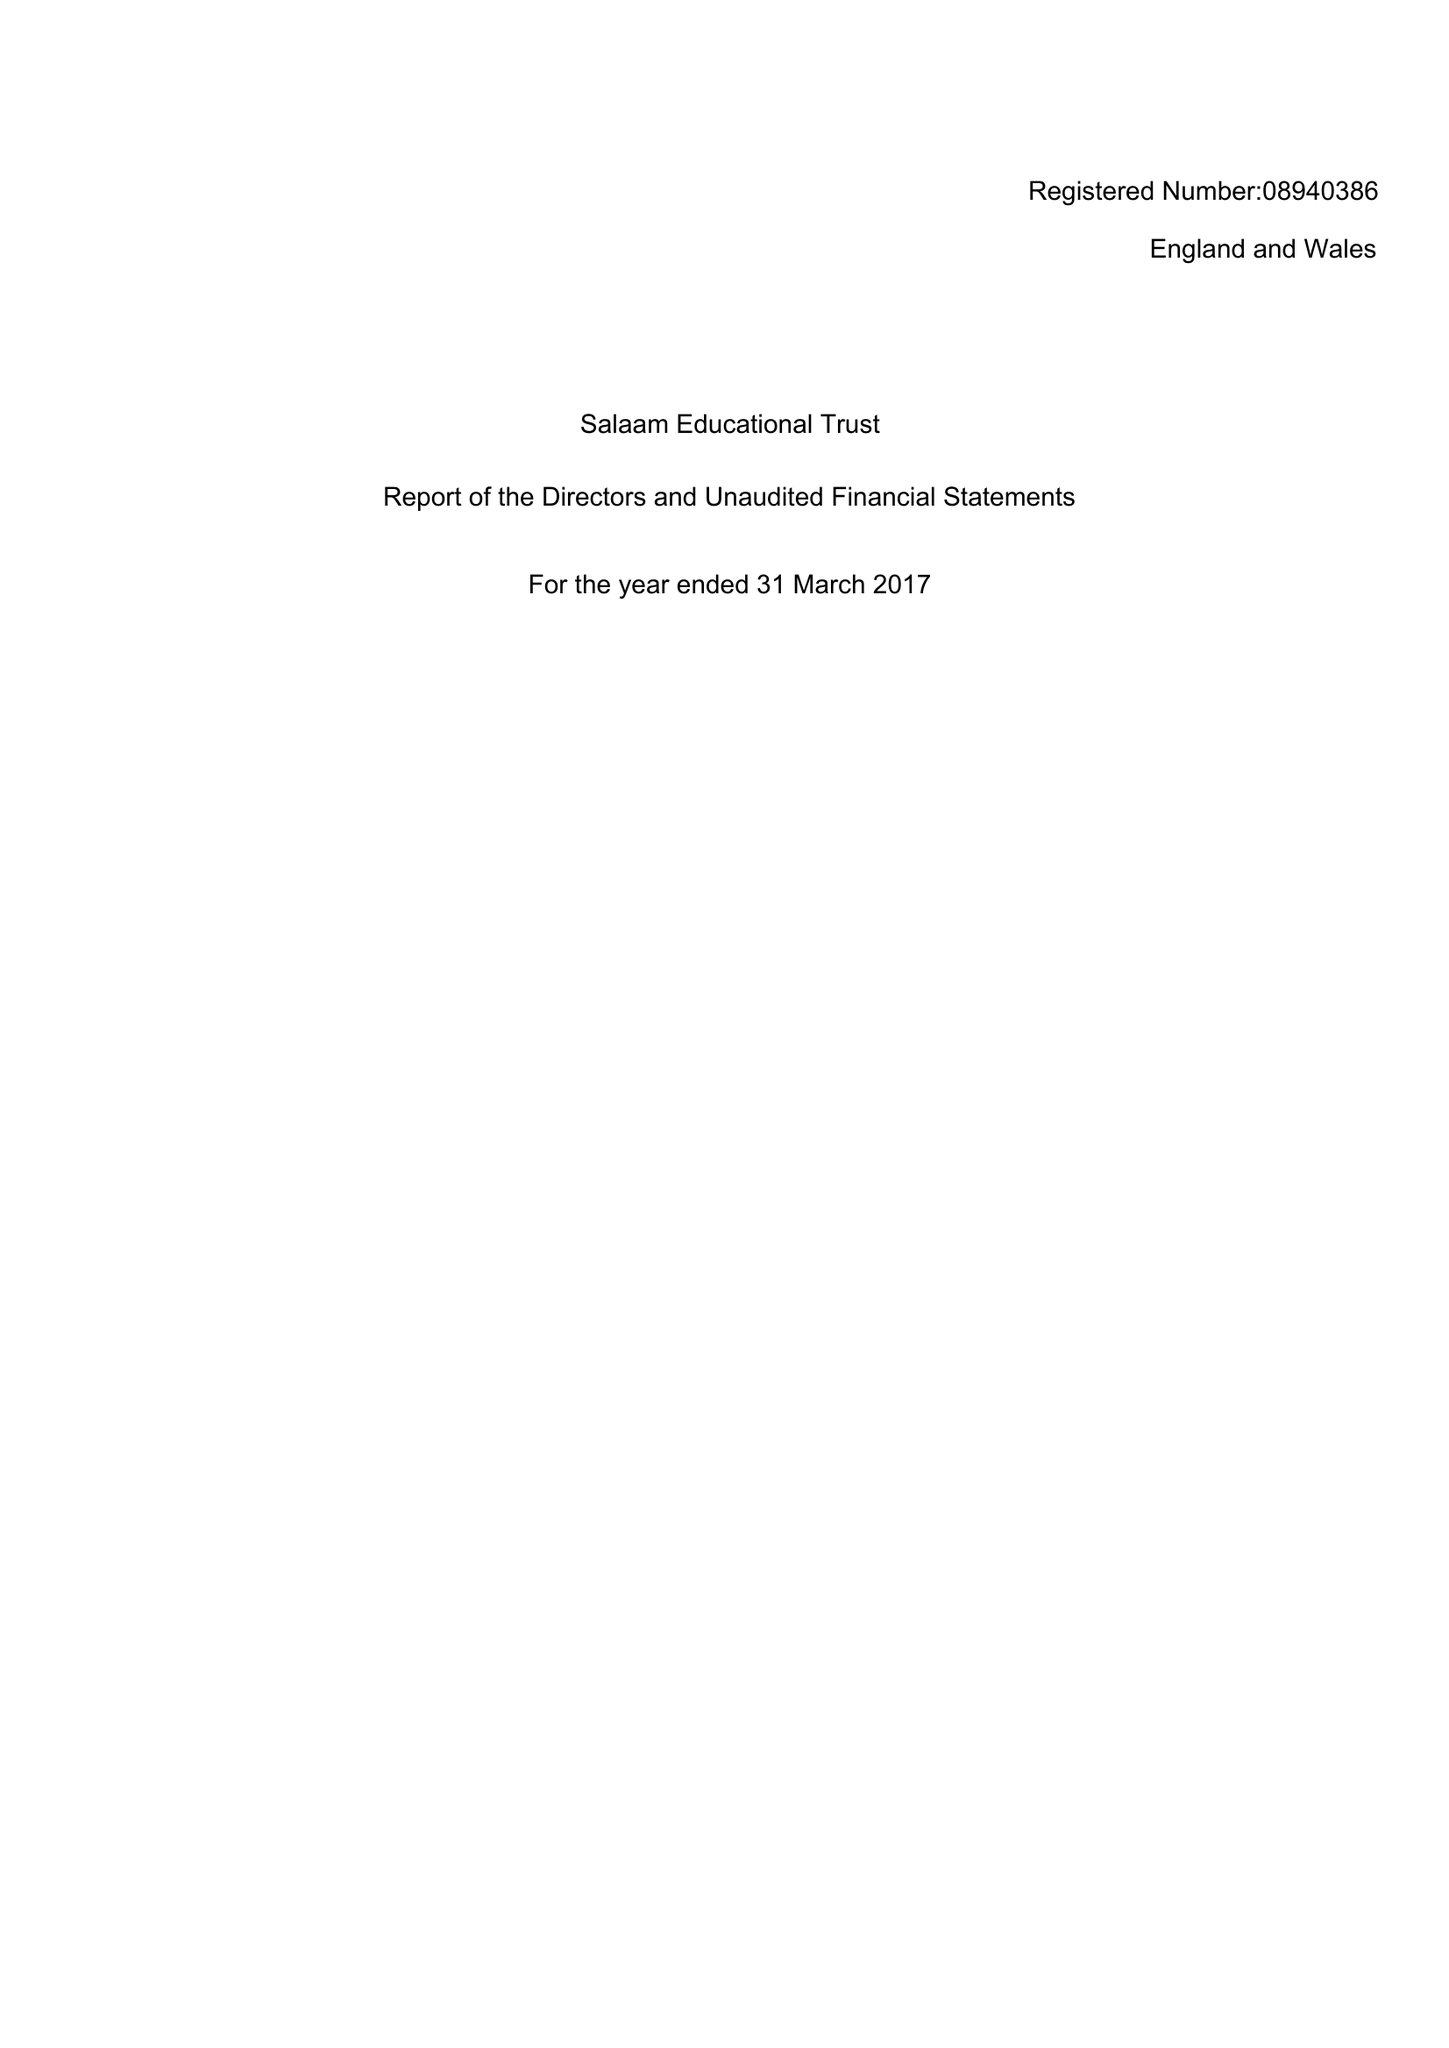What is the value for the address__street_line?
Answer the question using a single word or phrase. 32A WATLING STREET ROAD 